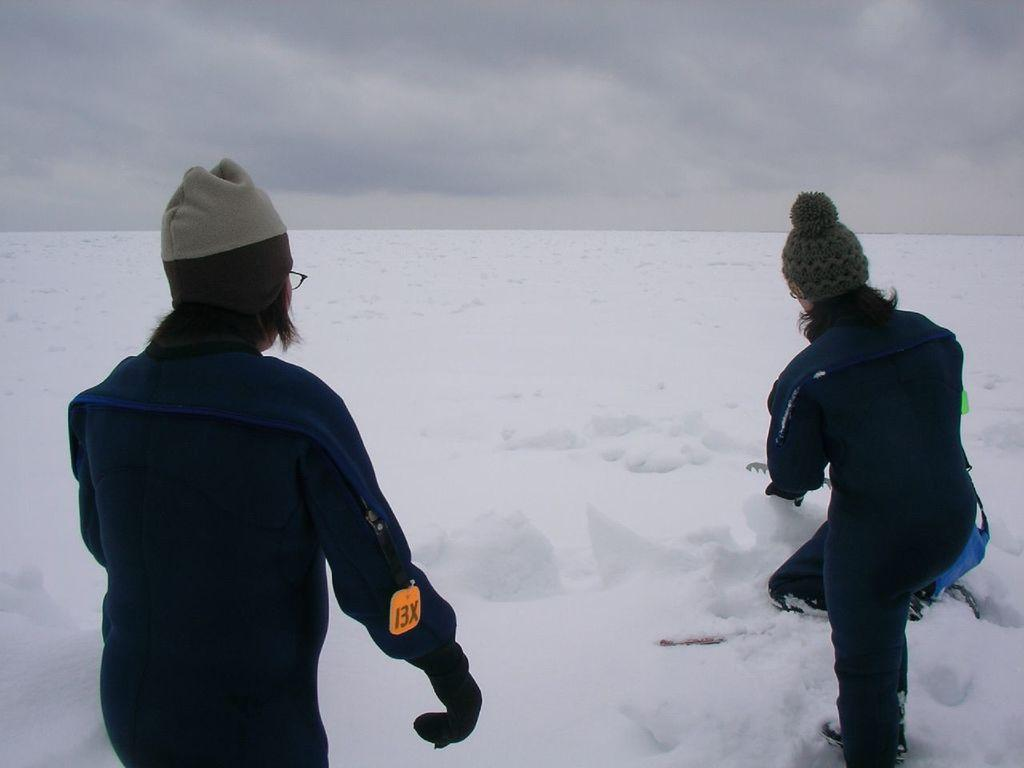What is the main subject of the image? The main subject of the image is people. Can you describe the people in the image? The people in the image are wearing caps and glasses. What is the setting of the image? There is snow at the bottom of the image. What type of furniture can be seen in the image? There is no furniture present in the image. How does the digestion process of the people in the image work? There is no information about the digestion process of the people in the image, as it is not relevant to the visual content. 